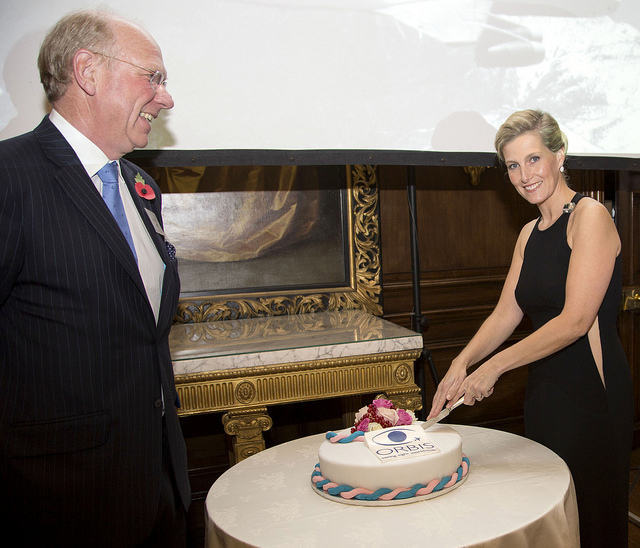Please identify all text content in this image. ORBIS 